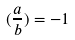Convert formula to latex. <formula><loc_0><loc_0><loc_500><loc_500>( \frac { a } { b } ) = - 1</formula> 